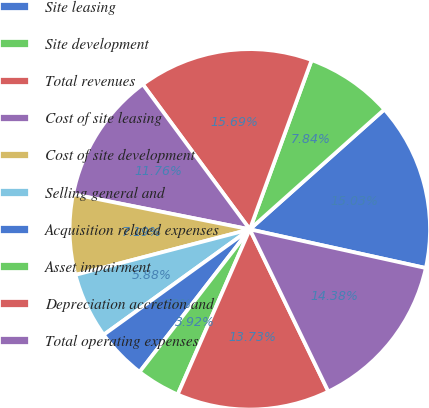Convert chart to OTSL. <chart><loc_0><loc_0><loc_500><loc_500><pie_chart><fcel>Site leasing<fcel>Site development<fcel>Total revenues<fcel>Cost of site leasing<fcel>Cost of site development<fcel>Selling general and<fcel>Acquisition related expenses<fcel>Asset impairment<fcel>Depreciation accretion and<fcel>Total operating expenses<nl><fcel>15.03%<fcel>7.84%<fcel>15.69%<fcel>11.76%<fcel>7.19%<fcel>5.88%<fcel>4.58%<fcel>3.92%<fcel>13.73%<fcel>14.38%<nl></chart> 